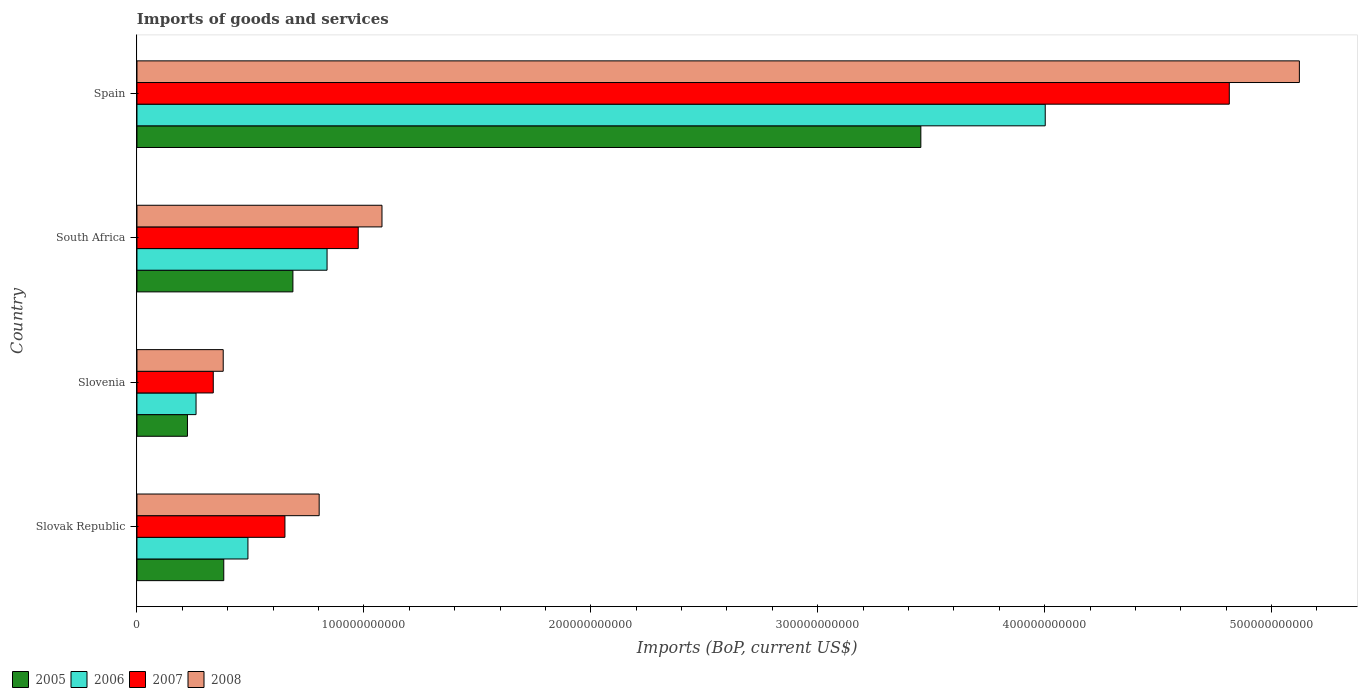How many groups of bars are there?
Offer a very short reply. 4. Are the number of bars per tick equal to the number of legend labels?
Your answer should be very brief. Yes. How many bars are there on the 1st tick from the top?
Provide a short and direct response. 4. What is the label of the 3rd group of bars from the top?
Provide a short and direct response. Slovenia. In how many cases, is the number of bars for a given country not equal to the number of legend labels?
Provide a succinct answer. 0. What is the amount spent on imports in 2006 in Slovenia?
Ensure brevity in your answer.  2.60e+1. Across all countries, what is the maximum amount spent on imports in 2007?
Keep it short and to the point. 4.81e+11. Across all countries, what is the minimum amount spent on imports in 2008?
Ensure brevity in your answer.  3.80e+1. In which country was the amount spent on imports in 2006 minimum?
Provide a short and direct response. Slovenia. What is the total amount spent on imports in 2008 in the graph?
Give a very brief answer. 7.39e+11. What is the difference between the amount spent on imports in 2007 in Slovenia and that in South Africa?
Your response must be concise. -6.39e+1. What is the difference between the amount spent on imports in 2005 in Slovenia and the amount spent on imports in 2008 in South Africa?
Ensure brevity in your answer.  -8.57e+1. What is the average amount spent on imports in 2005 per country?
Keep it short and to the point. 1.19e+11. What is the difference between the amount spent on imports in 2007 and amount spent on imports in 2005 in South Africa?
Provide a succinct answer. 2.88e+1. In how many countries, is the amount spent on imports in 2008 greater than 340000000000 US$?
Ensure brevity in your answer.  1. What is the ratio of the amount spent on imports in 2006 in Slovenia to that in South Africa?
Offer a terse response. 0.31. Is the amount spent on imports in 2005 in Slovak Republic less than that in South Africa?
Keep it short and to the point. Yes. What is the difference between the highest and the second highest amount spent on imports in 2005?
Make the answer very short. 2.77e+11. What is the difference between the highest and the lowest amount spent on imports in 2006?
Provide a short and direct response. 3.74e+11. In how many countries, is the amount spent on imports in 2008 greater than the average amount spent on imports in 2008 taken over all countries?
Keep it short and to the point. 1. Is the sum of the amount spent on imports in 2005 in Slovak Republic and Spain greater than the maximum amount spent on imports in 2006 across all countries?
Provide a short and direct response. No. Is it the case that in every country, the sum of the amount spent on imports in 2005 and amount spent on imports in 2007 is greater than the sum of amount spent on imports in 2008 and amount spent on imports in 2006?
Your answer should be compact. No. What does the 1st bar from the bottom in Spain represents?
Offer a very short reply. 2005. How many bars are there?
Your response must be concise. 16. Are all the bars in the graph horizontal?
Keep it short and to the point. Yes. What is the difference between two consecutive major ticks on the X-axis?
Make the answer very short. 1.00e+11. Are the values on the major ticks of X-axis written in scientific E-notation?
Your response must be concise. No. Does the graph contain any zero values?
Make the answer very short. No. Where does the legend appear in the graph?
Your response must be concise. Bottom left. What is the title of the graph?
Make the answer very short. Imports of goods and services. What is the label or title of the X-axis?
Offer a very short reply. Imports (BoP, current US$). What is the label or title of the Y-axis?
Your answer should be very brief. Country. What is the Imports (BoP, current US$) of 2005 in Slovak Republic?
Provide a succinct answer. 3.82e+1. What is the Imports (BoP, current US$) in 2006 in Slovak Republic?
Your answer should be compact. 4.89e+1. What is the Imports (BoP, current US$) of 2007 in Slovak Republic?
Your response must be concise. 6.52e+1. What is the Imports (BoP, current US$) of 2008 in Slovak Republic?
Your answer should be very brief. 8.03e+1. What is the Imports (BoP, current US$) of 2005 in Slovenia?
Ensure brevity in your answer.  2.22e+1. What is the Imports (BoP, current US$) of 2006 in Slovenia?
Your answer should be compact. 2.60e+1. What is the Imports (BoP, current US$) of 2007 in Slovenia?
Ensure brevity in your answer.  3.36e+1. What is the Imports (BoP, current US$) in 2008 in Slovenia?
Keep it short and to the point. 3.80e+1. What is the Imports (BoP, current US$) in 2005 in South Africa?
Provide a short and direct response. 6.87e+1. What is the Imports (BoP, current US$) of 2006 in South Africa?
Your answer should be very brief. 8.38e+1. What is the Imports (BoP, current US$) in 2007 in South Africa?
Your answer should be compact. 9.75e+1. What is the Imports (BoP, current US$) of 2008 in South Africa?
Your answer should be compact. 1.08e+11. What is the Imports (BoP, current US$) of 2005 in Spain?
Make the answer very short. 3.45e+11. What is the Imports (BoP, current US$) in 2006 in Spain?
Give a very brief answer. 4.00e+11. What is the Imports (BoP, current US$) of 2007 in Spain?
Make the answer very short. 4.81e+11. What is the Imports (BoP, current US$) of 2008 in Spain?
Ensure brevity in your answer.  5.12e+11. Across all countries, what is the maximum Imports (BoP, current US$) of 2005?
Your answer should be compact. 3.45e+11. Across all countries, what is the maximum Imports (BoP, current US$) of 2006?
Your answer should be very brief. 4.00e+11. Across all countries, what is the maximum Imports (BoP, current US$) of 2007?
Keep it short and to the point. 4.81e+11. Across all countries, what is the maximum Imports (BoP, current US$) of 2008?
Provide a succinct answer. 5.12e+11. Across all countries, what is the minimum Imports (BoP, current US$) in 2005?
Give a very brief answer. 2.22e+1. Across all countries, what is the minimum Imports (BoP, current US$) in 2006?
Give a very brief answer. 2.60e+1. Across all countries, what is the minimum Imports (BoP, current US$) in 2007?
Make the answer very short. 3.36e+1. Across all countries, what is the minimum Imports (BoP, current US$) in 2008?
Your response must be concise. 3.80e+1. What is the total Imports (BoP, current US$) of 2005 in the graph?
Give a very brief answer. 4.75e+11. What is the total Imports (BoP, current US$) in 2006 in the graph?
Your answer should be compact. 5.59e+11. What is the total Imports (BoP, current US$) in 2007 in the graph?
Provide a short and direct response. 6.78e+11. What is the total Imports (BoP, current US$) of 2008 in the graph?
Give a very brief answer. 7.39e+11. What is the difference between the Imports (BoP, current US$) in 2005 in Slovak Republic and that in Slovenia?
Offer a very short reply. 1.60e+1. What is the difference between the Imports (BoP, current US$) in 2006 in Slovak Republic and that in Slovenia?
Your answer should be compact. 2.29e+1. What is the difference between the Imports (BoP, current US$) of 2007 in Slovak Republic and that in Slovenia?
Give a very brief answer. 3.16e+1. What is the difference between the Imports (BoP, current US$) in 2008 in Slovak Republic and that in Slovenia?
Ensure brevity in your answer.  4.23e+1. What is the difference between the Imports (BoP, current US$) in 2005 in Slovak Republic and that in South Africa?
Make the answer very short. -3.05e+1. What is the difference between the Imports (BoP, current US$) of 2006 in Slovak Republic and that in South Africa?
Make the answer very short. -3.49e+1. What is the difference between the Imports (BoP, current US$) of 2007 in Slovak Republic and that in South Africa?
Offer a very short reply. -3.23e+1. What is the difference between the Imports (BoP, current US$) of 2008 in Slovak Republic and that in South Africa?
Keep it short and to the point. -2.77e+1. What is the difference between the Imports (BoP, current US$) of 2005 in Slovak Republic and that in Spain?
Ensure brevity in your answer.  -3.07e+11. What is the difference between the Imports (BoP, current US$) in 2006 in Slovak Republic and that in Spain?
Give a very brief answer. -3.51e+11. What is the difference between the Imports (BoP, current US$) of 2007 in Slovak Republic and that in Spain?
Ensure brevity in your answer.  -4.16e+11. What is the difference between the Imports (BoP, current US$) in 2008 in Slovak Republic and that in Spain?
Offer a terse response. -4.32e+11. What is the difference between the Imports (BoP, current US$) of 2005 in Slovenia and that in South Africa?
Your answer should be compact. -4.65e+1. What is the difference between the Imports (BoP, current US$) of 2006 in Slovenia and that in South Africa?
Your response must be concise. -5.77e+1. What is the difference between the Imports (BoP, current US$) in 2007 in Slovenia and that in South Africa?
Make the answer very short. -6.39e+1. What is the difference between the Imports (BoP, current US$) of 2008 in Slovenia and that in South Africa?
Provide a succinct answer. -7.00e+1. What is the difference between the Imports (BoP, current US$) in 2005 in Slovenia and that in Spain?
Offer a very short reply. -3.23e+11. What is the difference between the Imports (BoP, current US$) in 2006 in Slovenia and that in Spain?
Offer a terse response. -3.74e+11. What is the difference between the Imports (BoP, current US$) of 2007 in Slovenia and that in Spain?
Your answer should be very brief. -4.48e+11. What is the difference between the Imports (BoP, current US$) of 2008 in Slovenia and that in Spain?
Make the answer very short. -4.74e+11. What is the difference between the Imports (BoP, current US$) in 2005 in South Africa and that in Spain?
Your answer should be very brief. -2.77e+11. What is the difference between the Imports (BoP, current US$) of 2006 in South Africa and that in Spain?
Give a very brief answer. -3.16e+11. What is the difference between the Imports (BoP, current US$) in 2007 in South Africa and that in Spain?
Ensure brevity in your answer.  -3.84e+11. What is the difference between the Imports (BoP, current US$) of 2008 in South Africa and that in Spain?
Offer a very short reply. -4.04e+11. What is the difference between the Imports (BoP, current US$) of 2005 in Slovak Republic and the Imports (BoP, current US$) of 2006 in Slovenia?
Ensure brevity in your answer.  1.22e+1. What is the difference between the Imports (BoP, current US$) of 2005 in Slovak Republic and the Imports (BoP, current US$) of 2007 in Slovenia?
Offer a very short reply. 4.62e+09. What is the difference between the Imports (BoP, current US$) of 2005 in Slovak Republic and the Imports (BoP, current US$) of 2008 in Slovenia?
Offer a very short reply. 2.41e+08. What is the difference between the Imports (BoP, current US$) in 2006 in Slovak Republic and the Imports (BoP, current US$) in 2007 in Slovenia?
Offer a terse response. 1.53e+1. What is the difference between the Imports (BoP, current US$) of 2006 in Slovak Republic and the Imports (BoP, current US$) of 2008 in Slovenia?
Make the answer very short. 1.09e+1. What is the difference between the Imports (BoP, current US$) in 2007 in Slovak Republic and the Imports (BoP, current US$) in 2008 in Slovenia?
Your answer should be very brief. 2.72e+1. What is the difference between the Imports (BoP, current US$) in 2005 in Slovak Republic and the Imports (BoP, current US$) in 2006 in South Africa?
Your response must be concise. -4.55e+1. What is the difference between the Imports (BoP, current US$) in 2005 in Slovak Republic and the Imports (BoP, current US$) in 2007 in South Africa?
Keep it short and to the point. -5.93e+1. What is the difference between the Imports (BoP, current US$) of 2005 in Slovak Republic and the Imports (BoP, current US$) of 2008 in South Africa?
Ensure brevity in your answer.  -6.97e+1. What is the difference between the Imports (BoP, current US$) in 2006 in Slovak Republic and the Imports (BoP, current US$) in 2007 in South Africa?
Keep it short and to the point. -4.86e+1. What is the difference between the Imports (BoP, current US$) in 2006 in Slovak Republic and the Imports (BoP, current US$) in 2008 in South Africa?
Keep it short and to the point. -5.91e+1. What is the difference between the Imports (BoP, current US$) in 2007 in Slovak Republic and the Imports (BoP, current US$) in 2008 in South Africa?
Your response must be concise. -4.28e+1. What is the difference between the Imports (BoP, current US$) of 2005 in Slovak Republic and the Imports (BoP, current US$) of 2006 in Spain?
Provide a succinct answer. -3.62e+11. What is the difference between the Imports (BoP, current US$) in 2005 in Slovak Republic and the Imports (BoP, current US$) in 2007 in Spain?
Keep it short and to the point. -4.43e+11. What is the difference between the Imports (BoP, current US$) in 2005 in Slovak Republic and the Imports (BoP, current US$) in 2008 in Spain?
Your answer should be compact. -4.74e+11. What is the difference between the Imports (BoP, current US$) in 2006 in Slovak Republic and the Imports (BoP, current US$) in 2007 in Spain?
Provide a succinct answer. -4.32e+11. What is the difference between the Imports (BoP, current US$) of 2006 in Slovak Republic and the Imports (BoP, current US$) of 2008 in Spain?
Offer a very short reply. -4.63e+11. What is the difference between the Imports (BoP, current US$) of 2007 in Slovak Republic and the Imports (BoP, current US$) of 2008 in Spain?
Your answer should be very brief. -4.47e+11. What is the difference between the Imports (BoP, current US$) in 2005 in Slovenia and the Imports (BoP, current US$) in 2006 in South Africa?
Your response must be concise. -6.15e+1. What is the difference between the Imports (BoP, current US$) in 2005 in Slovenia and the Imports (BoP, current US$) in 2007 in South Africa?
Your answer should be compact. -7.53e+1. What is the difference between the Imports (BoP, current US$) of 2005 in Slovenia and the Imports (BoP, current US$) of 2008 in South Africa?
Offer a terse response. -8.57e+1. What is the difference between the Imports (BoP, current US$) of 2006 in Slovenia and the Imports (BoP, current US$) of 2007 in South Africa?
Make the answer very short. -7.15e+1. What is the difference between the Imports (BoP, current US$) of 2006 in Slovenia and the Imports (BoP, current US$) of 2008 in South Africa?
Provide a short and direct response. -8.19e+1. What is the difference between the Imports (BoP, current US$) in 2007 in Slovenia and the Imports (BoP, current US$) in 2008 in South Africa?
Give a very brief answer. -7.43e+1. What is the difference between the Imports (BoP, current US$) of 2005 in Slovenia and the Imports (BoP, current US$) of 2006 in Spain?
Offer a terse response. -3.78e+11. What is the difference between the Imports (BoP, current US$) in 2005 in Slovenia and the Imports (BoP, current US$) in 2007 in Spain?
Provide a succinct answer. -4.59e+11. What is the difference between the Imports (BoP, current US$) in 2005 in Slovenia and the Imports (BoP, current US$) in 2008 in Spain?
Keep it short and to the point. -4.90e+11. What is the difference between the Imports (BoP, current US$) of 2006 in Slovenia and the Imports (BoP, current US$) of 2007 in Spain?
Give a very brief answer. -4.55e+11. What is the difference between the Imports (BoP, current US$) of 2006 in Slovenia and the Imports (BoP, current US$) of 2008 in Spain?
Keep it short and to the point. -4.86e+11. What is the difference between the Imports (BoP, current US$) of 2007 in Slovenia and the Imports (BoP, current US$) of 2008 in Spain?
Your answer should be compact. -4.79e+11. What is the difference between the Imports (BoP, current US$) in 2005 in South Africa and the Imports (BoP, current US$) in 2006 in Spain?
Offer a very short reply. -3.32e+11. What is the difference between the Imports (BoP, current US$) in 2005 in South Africa and the Imports (BoP, current US$) in 2007 in Spain?
Provide a succinct answer. -4.13e+11. What is the difference between the Imports (BoP, current US$) of 2005 in South Africa and the Imports (BoP, current US$) of 2008 in Spain?
Your answer should be very brief. -4.44e+11. What is the difference between the Imports (BoP, current US$) of 2006 in South Africa and the Imports (BoP, current US$) of 2007 in Spain?
Keep it short and to the point. -3.98e+11. What is the difference between the Imports (BoP, current US$) in 2006 in South Africa and the Imports (BoP, current US$) in 2008 in Spain?
Provide a short and direct response. -4.28e+11. What is the difference between the Imports (BoP, current US$) of 2007 in South Africa and the Imports (BoP, current US$) of 2008 in Spain?
Ensure brevity in your answer.  -4.15e+11. What is the average Imports (BoP, current US$) in 2005 per country?
Provide a short and direct response. 1.19e+11. What is the average Imports (BoP, current US$) of 2006 per country?
Provide a succinct answer. 1.40e+11. What is the average Imports (BoP, current US$) in 2007 per country?
Keep it short and to the point. 1.69e+11. What is the average Imports (BoP, current US$) of 2008 per country?
Keep it short and to the point. 1.85e+11. What is the difference between the Imports (BoP, current US$) of 2005 and Imports (BoP, current US$) of 2006 in Slovak Republic?
Your answer should be compact. -1.07e+1. What is the difference between the Imports (BoP, current US$) of 2005 and Imports (BoP, current US$) of 2007 in Slovak Republic?
Your response must be concise. -2.70e+1. What is the difference between the Imports (BoP, current US$) in 2005 and Imports (BoP, current US$) in 2008 in Slovak Republic?
Ensure brevity in your answer.  -4.20e+1. What is the difference between the Imports (BoP, current US$) of 2006 and Imports (BoP, current US$) of 2007 in Slovak Republic?
Your answer should be very brief. -1.63e+1. What is the difference between the Imports (BoP, current US$) of 2006 and Imports (BoP, current US$) of 2008 in Slovak Republic?
Your response must be concise. -3.14e+1. What is the difference between the Imports (BoP, current US$) of 2007 and Imports (BoP, current US$) of 2008 in Slovak Republic?
Keep it short and to the point. -1.51e+1. What is the difference between the Imports (BoP, current US$) of 2005 and Imports (BoP, current US$) of 2006 in Slovenia?
Ensure brevity in your answer.  -3.79e+09. What is the difference between the Imports (BoP, current US$) in 2005 and Imports (BoP, current US$) in 2007 in Slovenia?
Offer a very short reply. -1.14e+1. What is the difference between the Imports (BoP, current US$) in 2005 and Imports (BoP, current US$) in 2008 in Slovenia?
Ensure brevity in your answer.  -1.58e+1. What is the difference between the Imports (BoP, current US$) in 2006 and Imports (BoP, current US$) in 2007 in Slovenia?
Ensure brevity in your answer.  -7.59e+09. What is the difference between the Imports (BoP, current US$) of 2006 and Imports (BoP, current US$) of 2008 in Slovenia?
Give a very brief answer. -1.20e+1. What is the difference between the Imports (BoP, current US$) in 2007 and Imports (BoP, current US$) in 2008 in Slovenia?
Your answer should be compact. -4.38e+09. What is the difference between the Imports (BoP, current US$) in 2005 and Imports (BoP, current US$) in 2006 in South Africa?
Provide a succinct answer. -1.50e+1. What is the difference between the Imports (BoP, current US$) in 2005 and Imports (BoP, current US$) in 2007 in South Africa?
Ensure brevity in your answer.  -2.88e+1. What is the difference between the Imports (BoP, current US$) in 2005 and Imports (BoP, current US$) in 2008 in South Africa?
Offer a terse response. -3.93e+1. What is the difference between the Imports (BoP, current US$) in 2006 and Imports (BoP, current US$) in 2007 in South Africa?
Ensure brevity in your answer.  -1.37e+1. What is the difference between the Imports (BoP, current US$) of 2006 and Imports (BoP, current US$) of 2008 in South Africa?
Provide a short and direct response. -2.42e+1. What is the difference between the Imports (BoP, current US$) of 2007 and Imports (BoP, current US$) of 2008 in South Africa?
Offer a very short reply. -1.05e+1. What is the difference between the Imports (BoP, current US$) in 2005 and Imports (BoP, current US$) in 2006 in Spain?
Provide a short and direct response. -5.48e+1. What is the difference between the Imports (BoP, current US$) in 2005 and Imports (BoP, current US$) in 2007 in Spain?
Your answer should be compact. -1.36e+11. What is the difference between the Imports (BoP, current US$) of 2005 and Imports (BoP, current US$) of 2008 in Spain?
Make the answer very short. -1.67e+11. What is the difference between the Imports (BoP, current US$) in 2006 and Imports (BoP, current US$) in 2007 in Spain?
Provide a succinct answer. -8.11e+1. What is the difference between the Imports (BoP, current US$) of 2006 and Imports (BoP, current US$) of 2008 in Spain?
Provide a short and direct response. -1.12e+11. What is the difference between the Imports (BoP, current US$) of 2007 and Imports (BoP, current US$) of 2008 in Spain?
Your answer should be very brief. -3.09e+1. What is the ratio of the Imports (BoP, current US$) of 2005 in Slovak Republic to that in Slovenia?
Your response must be concise. 1.72. What is the ratio of the Imports (BoP, current US$) in 2006 in Slovak Republic to that in Slovenia?
Provide a short and direct response. 1.88. What is the ratio of the Imports (BoP, current US$) in 2007 in Slovak Republic to that in Slovenia?
Your response must be concise. 1.94. What is the ratio of the Imports (BoP, current US$) in 2008 in Slovak Republic to that in Slovenia?
Offer a terse response. 2.11. What is the ratio of the Imports (BoP, current US$) in 2005 in Slovak Republic to that in South Africa?
Your answer should be very brief. 0.56. What is the ratio of the Imports (BoP, current US$) in 2006 in Slovak Republic to that in South Africa?
Offer a terse response. 0.58. What is the ratio of the Imports (BoP, current US$) in 2007 in Slovak Republic to that in South Africa?
Offer a terse response. 0.67. What is the ratio of the Imports (BoP, current US$) in 2008 in Slovak Republic to that in South Africa?
Give a very brief answer. 0.74. What is the ratio of the Imports (BoP, current US$) in 2005 in Slovak Republic to that in Spain?
Give a very brief answer. 0.11. What is the ratio of the Imports (BoP, current US$) of 2006 in Slovak Republic to that in Spain?
Offer a terse response. 0.12. What is the ratio of the Imports (BoP, current US$) of 2007 in Slovak Republic to that in Spain?
Provide a succinct answer. 0.14. What is the ratio of the Imports (BoP, current US$) in 2008 in Slovak Republic to that in Spain?
Give a very brief answer. 0.16. What is the ratio of the Imports (BoP, current US$) in 2005 in Slovenia to that in South Africa?
Offer a very short reply. 0.32. What is the ratio of the Imports (BoP, current US$) in 2006 in Slovenia to that in South Africa?
Your answer should be compact. 0.31. What is the ratio of the Imports (BoP, current US$) in 2007 in Slovenia to that in South Africa?
Make the answer very short. 0.34. What is the ratio of the Imports (BoP, current US$) in 2008 in Slovenia to that in South Africa?
Give a very brief answer. 0.35. What is the ratio of the Imports (BoP, current US$) in 2005 in Slovenia to that in Spain?
Offer a very short reply. 0.06. What is the ratio of the Imports (BoP, current US$) in 2006 in Slovenia to that in Spain?
Provide a short and direct response. 0.07. What is the ratio of the Imports (BoP, current US$) in 2007 in Slovenia to that in Spain?
Provide a succinct answer. 0.07. What is the ratio of the Imports (BoP, current US$) of 2008 in Slovenia to that in Spain?
Offer a terse response. 0.07. What is the ratio of the Imports (BoP, current US$) of 2005 in South Africa to that in Spain?
Provide a short and direct response. 0.2. What is the ratio of the Imports (BoP, current US$) in 2006 in South Africa to that in Spain?
Give a very brief answer. 0.21. What is the ratio of the Imports (BoP, current US$) in 2007 in South Africa to that in Spain?
Provide a short and direct response. 0.2. What is the ratio of the Imports (BoP, current US$) in 2008 in South Africa to that in Spain?
Make the answer very short. 0.21. What is the difference between the highest and the second highest Imports (BoP, current US$) in 2005?
Ensure brevity in your answer.  2.77e+11. What is the difference between the highest and the second highest Imports (BoP, current US$) of 2006?
Keep it short and to the point. 3.16e+11. What is the difference between the highest and the second highest Imports (BoP, current US$) of 2007?
Provide a succinct answer. 3.84e+11. What is the difference between the highest and the second highest Imports (BoP, current US$) of 2008?
Make the answer very short. 4.04e+11. What is the difference between the highest and the lowest Imports (BoP, current US$) of 2005?
Make the answer very short. 3.23e+11. What is the difference between the highest and the lowest Imports (BoP, current US$) in 2006?
Your answer should be compact. 3.74e+11. What is the difference between the highest and the lowest Imports (BoP, current US$) of 2007?
Your response must be concise. 4.48e+11. What is the difference between the highest and the lowest Imports (BoP, current US$) of 2008?
Ensure brevity in your answer.  4.74e+11. 